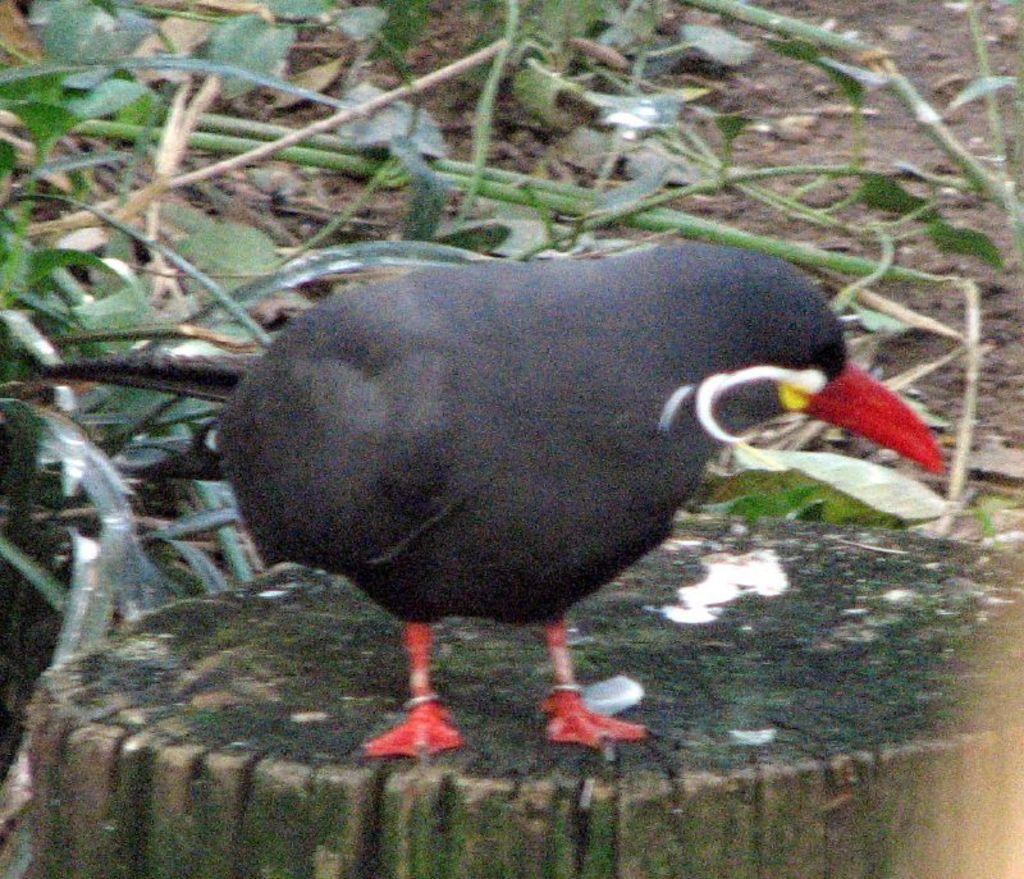Could you give a brief overview of what you see in this image? In the center of the picture we can see a bird, on the trunk of a tree. In the background there are stems and leaves and there are dry leaves and soil. 